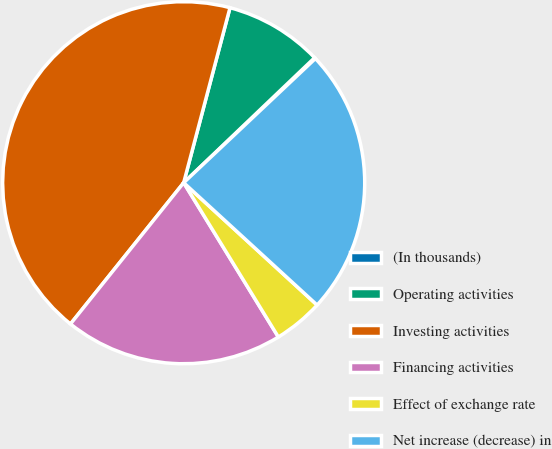Convert chart. <chart><loc_0><loc_0><loc_500><loc_500><pie_chart><fcel>(In thousands)<fcel>Operating activities<fcel>Investing activities<fcel>Financing activities<fcel>Effect of exchange rate<fcel>Net increase (decrease) in<nl><fcel>0.1%<fcel>8.75%<fcel>43.36%<fcel>19.51%<fcel>4.43%<fcel>23.84%<nl></chart> 